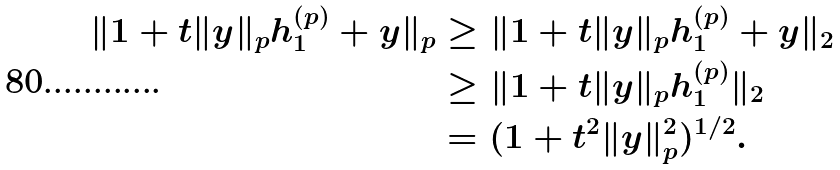<formula> <loc_0><loc_0><loc_500><loc_500>\| 1 + t \| y \| _ { p } h ^ { ( p ) } _ { 1 } + y \| _ { p } & \geq \| 1 + t \| y \| _ { p } h _ { 1 } ^ { ( p ) } + y \| _ { 2 } \\ & \geq \| 1 + t \| y \| _ { p } h ^ { ( p ) } _ { 1 } \| _ { 2 } \\ & = ( 1 + t ^ { 2 } \| y \| _ { p } ^ { 2 } ) ^ { 1 / 2 } .</formula> 